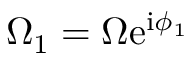Convert formula to latex. <formula><loc_0><loc_0><loc_500><loc_500>\Omega _ { 1 } = \Omega e ^ { i \phi _ { 1 } }</formula> 